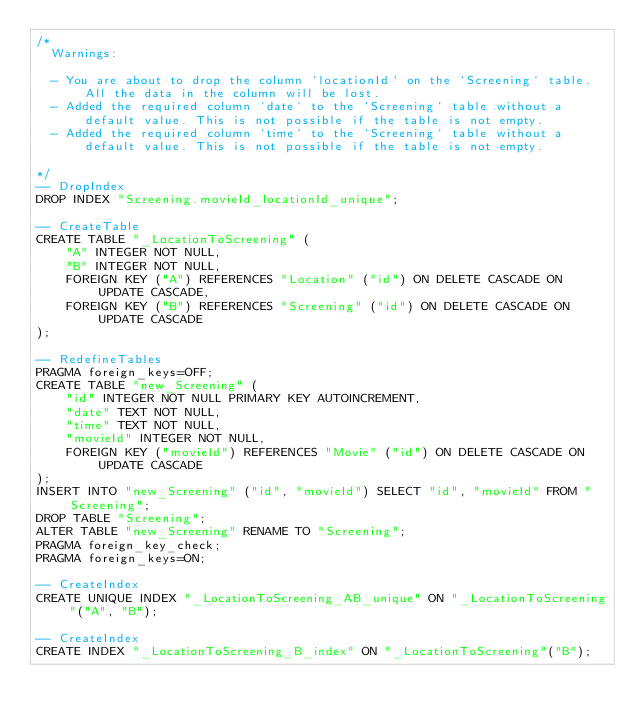Convert code to text. <code><loc_0><loc_0><loc_500><loc_500><_SQL_>/*
  Warnings:

  - You are about to drop the column `locationId` on the `Screening` table. All the data in the column will be lost.
  - Added the required column `date` to the `Screening` table without a default value. This is not possible if the table is not empty.
  - Added the required column `time` to the `Screening` table without a default value. This is not possible if the table is not empty.

*/
-- DropIndex
DROP INDEX "Screening.movieId_locationId_unique";

-- CreateTable
CREATE TABLE "_LocationToScreening" (
    "A" INTEGER NOT NULL,
    "B" INTEGER NOT NULL,
    FOREIGN KEY ("A") REFERENCES "Location" ("id") ON DELETE CASCADE ON UPDATE CASCADE,
    FOREIGN KEY ("B") REFERENCES "Screening" ("id") ON DELETE CASCADE ON UPDATE CASCADE
);

-- RedefineTables
PRAGMA foreign_keys=OFF;
CREATE TABLE "new_Screening" (
    "id" INTEGER NOT NULL PRIMARY KEY AUTOINCREMENT,
    "date" TEXT NOT NULL,
    "time" TEXT NOT NULL,
    "movieId" INTEGER NOT NULL,
    FOREIGN KEY ("movieId") REFERENCES "Movie" ("id") ON DELETE CASCADE ON UPDATE CASCADE
);
INSERT INTO "new_Screening" ("id", "movieId") SELECT "id", "movieId" FROM "Screening";
DROP TABLE "Screening";
ALTER TABLE "new_Screening" RENAME TO "Screening";
PRAGMA foreign_key_check;
PRAGMA foreign_keys=ON;

-- CreateIndex
CREATE UNIQUE INDEX "_LocationToScreening_AB_unique" ON "_LocationToScreening"("A", "B");

-- CreateIndex
CREATE INDEX "_LocationToScreening_B_index" ON "_LocationToScreening"("B");
</code> 